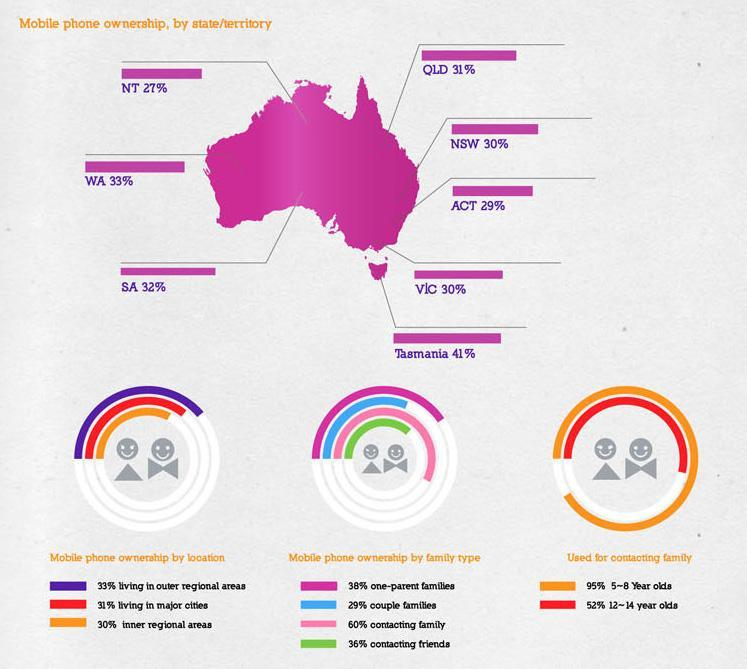What percentage of children in the age group of 12-14 years old used mobile phones for contacting families in Australia?
Answer the question with a short phrase. 52% Which state in Australia has the highest mobile ownership rate? Tasmania What percentage of children in the age group of 5-8 years old used mobile phones for contacting families in Australia? 95% What is the mobile ownership rate in New South Wales? 30% What is the mobile ownership rate in Western Australia? 33% Which territory in Australia has the least mobile ownership rate? NT What percentage is the mobile phone ownership in couple families in Australia? 29% 